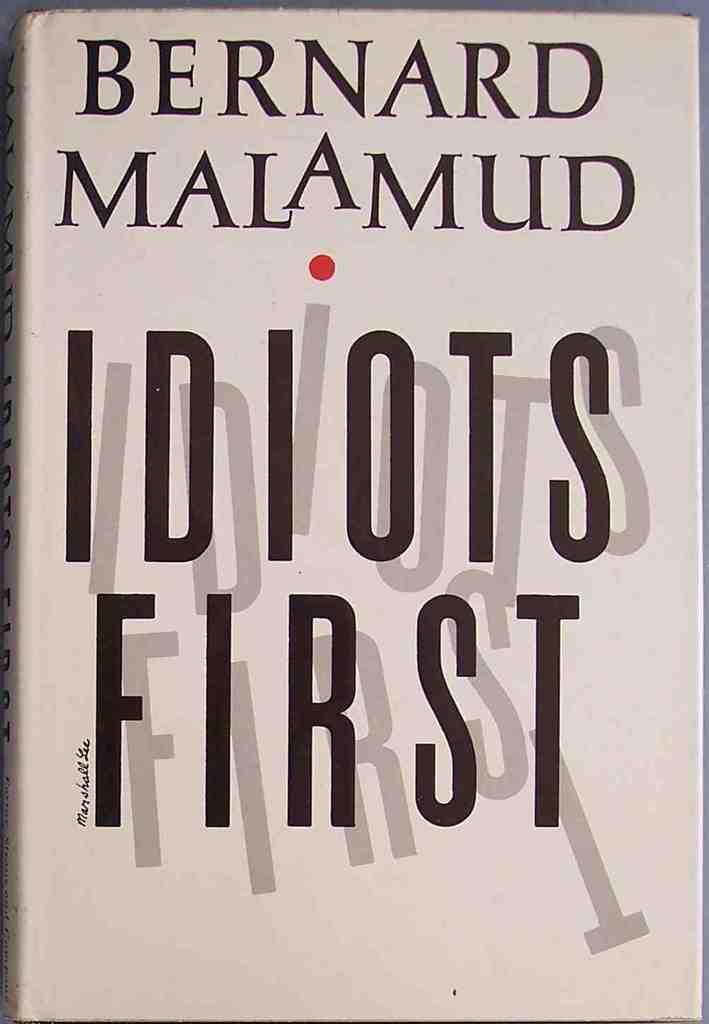This says idiots what?
Ensure brevity in your answer.  First. 